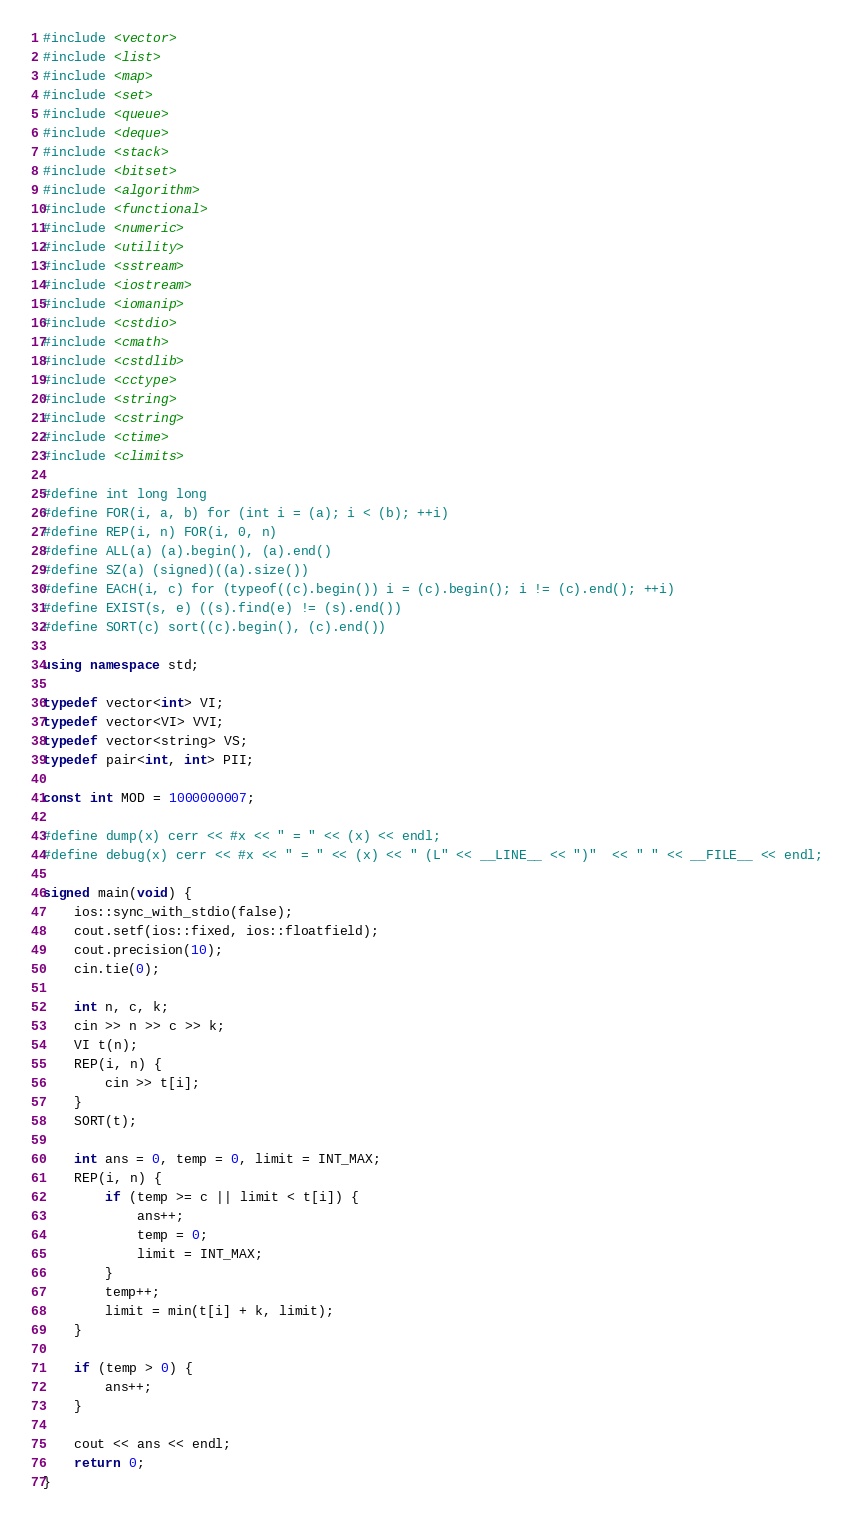Convert code to text. <code><loc_0><loc_0><loc_500><loc_500><_C++_>#include <vector>
#include <list>
#include <map>
#include <set>
#include <queue>
#include <deque>
#include <stack>
#include <bitset>
#include <algorithm>
#include <functional>
#include <numeric>
#include <utility>
#include <sstream>
#include <iostream>
#include <iomanip>
#include <cstdio>
#include <cmath>
#include <cstdlib>
#include <cctype>
#include <string>
#include <cstring>
#include <ctime>
#include <climits>

#define int long long
#define FOR(i, a, b) for (int i = (a); i < (b); ++i)
#define REP(i, n) FOR(i, 0, n)
#define ALL(a) (a).begin(), (a).end()
#define SZ(a) (signed)((a).size())
#define EACH(i, c) for (typeof((c).begin()) i = (c).begin(); i != (c).end(); ++i)
#define EXIST(s, e) ((s).find(e) != (s).end())
#define SORT(c) sort((c).begin(), (c).end())

using namespace std;

typedef vector<int> VI;
typedef vector<VI> VVI;
typedef vector<string> VS;
typedef pair<int, int> PII;

const int MOD = 1000000007;

#define dump(x) cerr << #x << " = " << (x) << endl;
#define debug(x) cerr << #x << " = " << (x) << " (L" << __LINE__ << ")"  << " " << __FILE__ << endl;

signed main(void) {
    ios::sync_with_stdio(false);
    cout.setf(ios::fixed, ios::floatfield);
    cout.precision(10);
    cin.tie(0);

    int n, c, k;
    cin >> n >> c >> k;
    VI t(n);
    REP(i, n) {
        cin >> t[i];
    }
    SORT(t);

    int ans = 0, temp = 0, limit = INT_MAX;
    REP(i, n) {
        if (temp >= c || limit < t[i]) {
            ans++;
            temp = 0;
            limit = INT_MAX;
        }
        temp++;
        limit = min(t[i] + k, limit);
    }

    if (temp > 0) {
        ans++;
    }

    cout << ans << endl;
    return 0;
}
</code> 